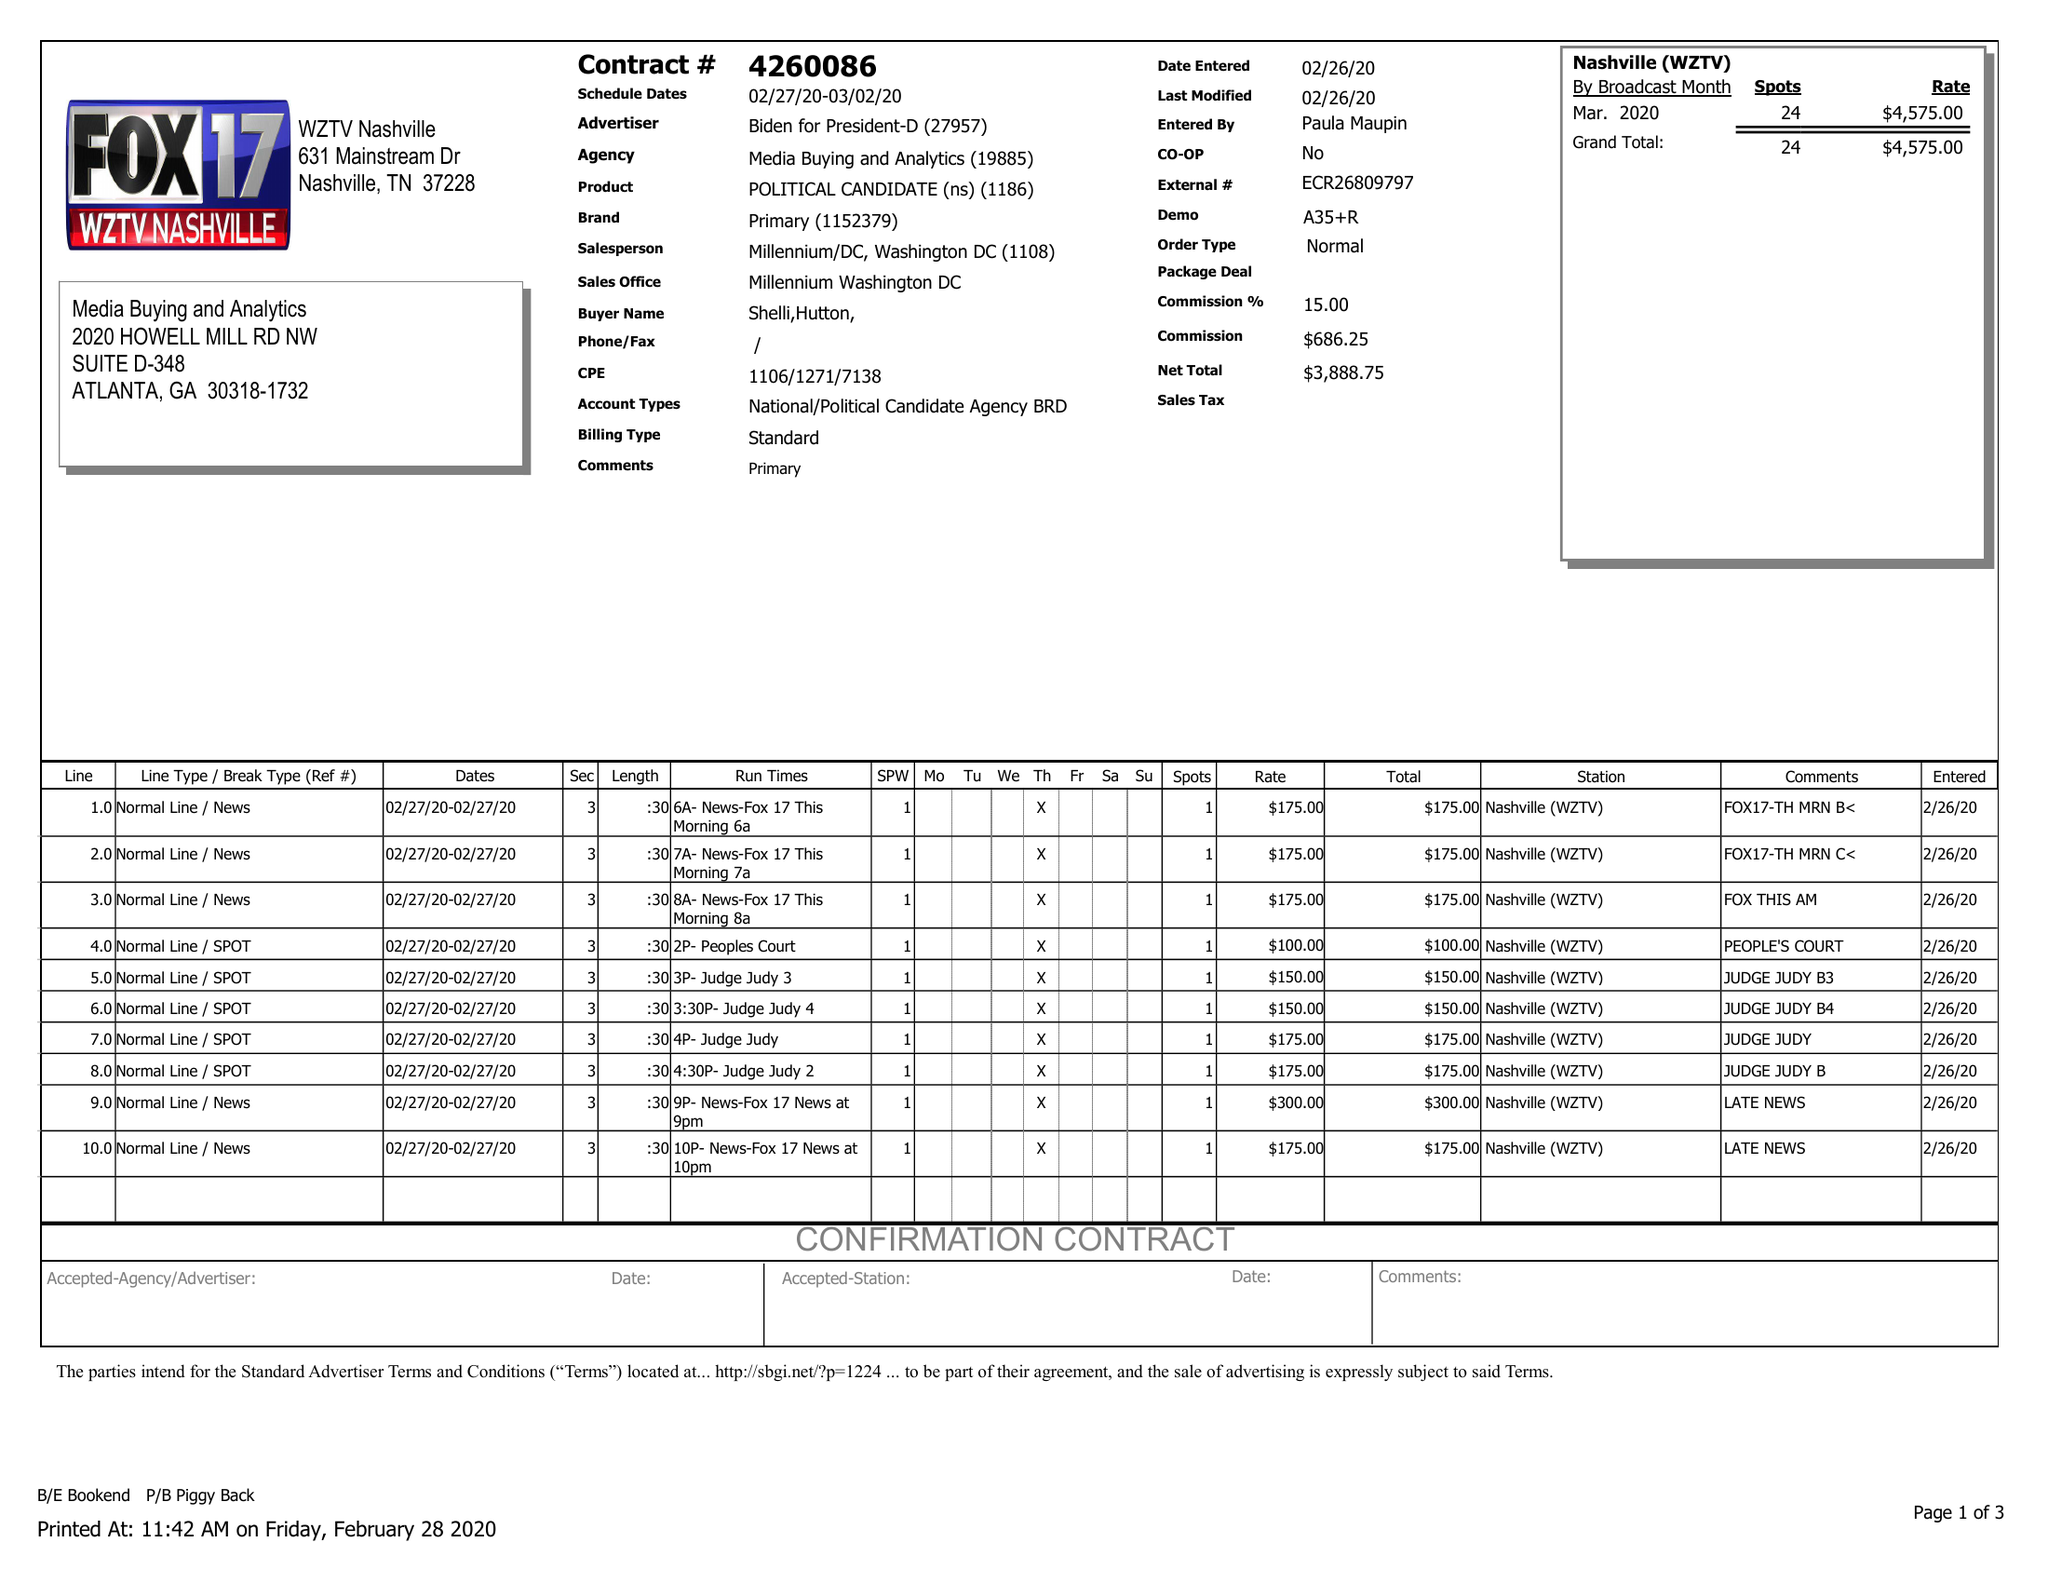What is the value for the advertiser?
Answer the question using a single word or phrase. BIDEN FOR PRESIDENT-D 